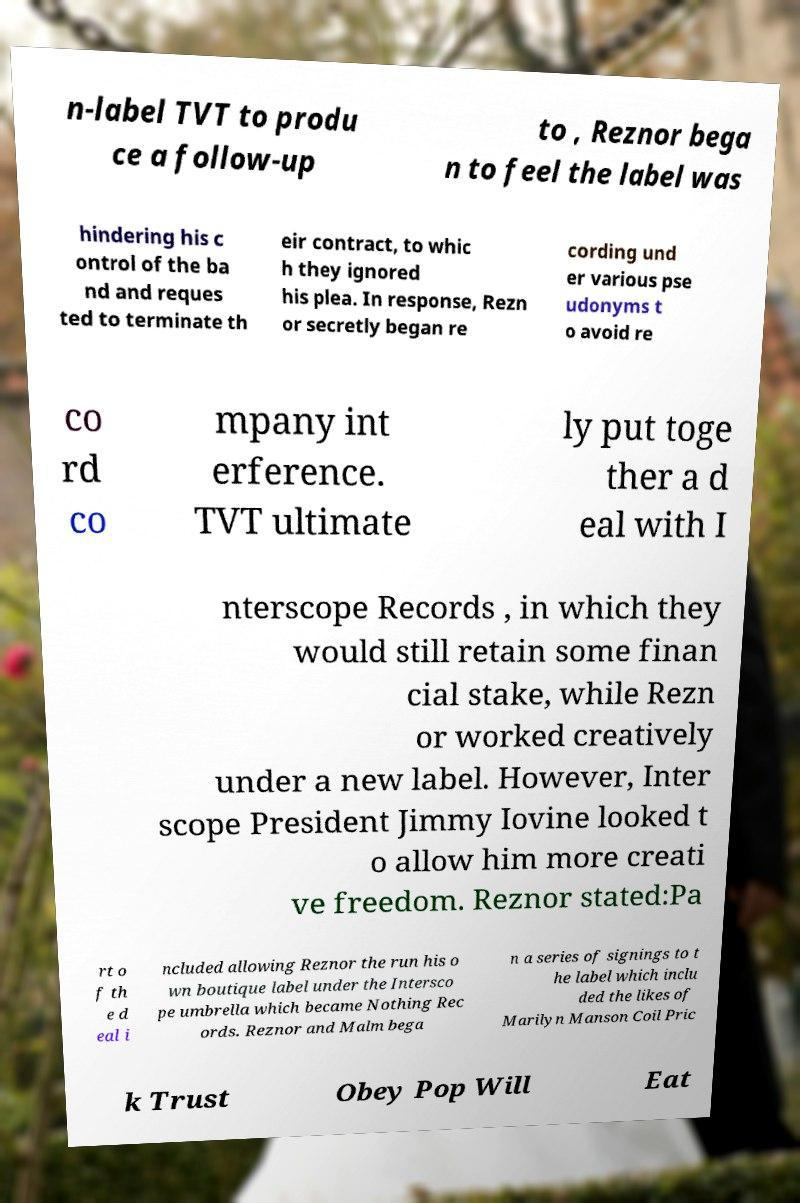I need the written content from this picture converted into text. Can you do that? n-label TVT to produ ce a follow-up to , Reznor bega n to feel the label was hindering his c ontrol of the ba nd and reques ted to terminate th eir contract, to whic h they ignored his plea. In response, Rezn or secretly began re cording und er various pse udonyms t o avoid re co rd co mpany int erference. TVT ultimate ly put toge ther a d eal with I nterscope Records , in which they would still retain some finan cial stake, while Rezn or worked creatively under a new label. However, Inter scope President Jimmy Iovine looked t o allow him more creati ve freedom. Reznor stated:Pa rt o f th e d eal i ncluded allowing Reznor the run his o wn boutique label under the Intersco pe umbrella which became Nothing Rec ords. Reznor and Malm bega n a series of signings to t he label which inclu ded the likes of Marilyn Manson Coil Pric k Trust Obey Pop Will Eat 